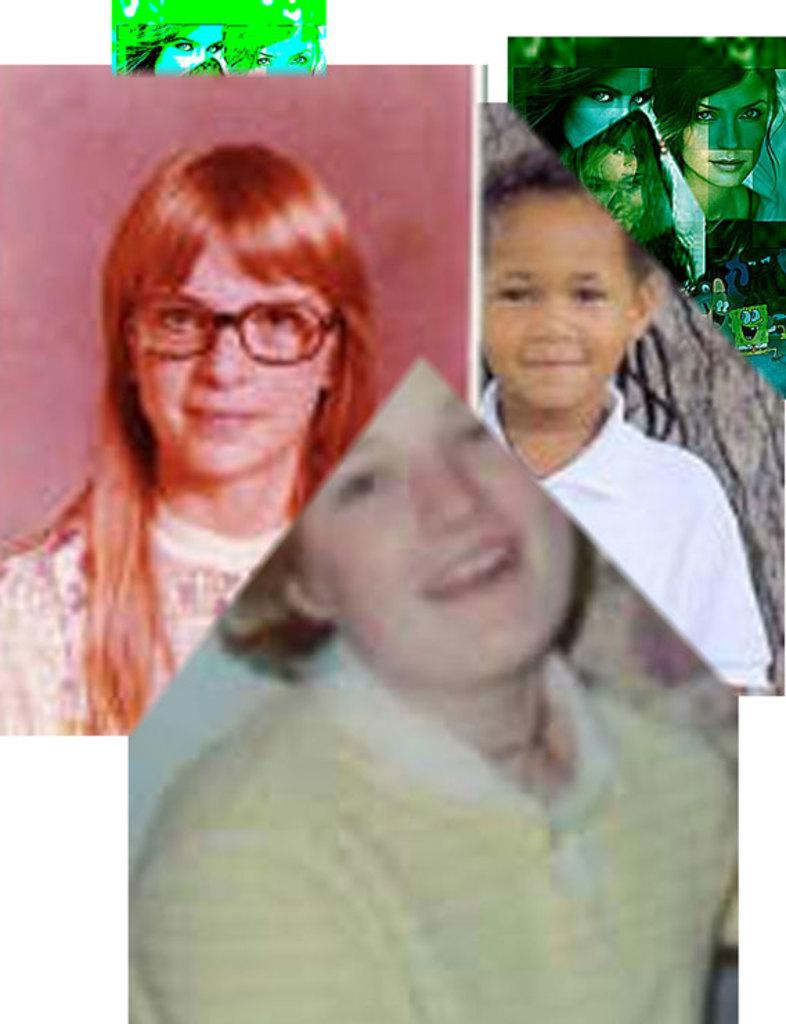What type of artwork is depicted in the image? The image is a collage. Can you describe the subjects in the image? There are people and cartoon images in the image. What natural element is present in the image? There is a tree trunk in the image. How many shoes are visible in the image? There are no shoes present in the image. What is the jail's location in the image? There is no jail present in the image. 